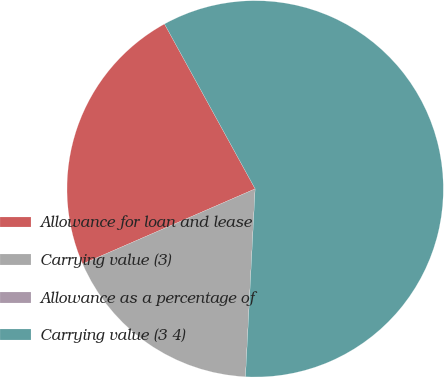Convert chart to OTSL. <chart><loc_0><loc_0><loc_500><loc_500><pie_chart><fcel>Allowance for loan and lease<fcel>Carrying value (3)<fcel>Allowance as a percentage of<fcel>Carrying value (3 4)<nl><fcel>23.53%<fcel>17.65%<fcel>0.0%<fcel>58.82%<nl></chart> 